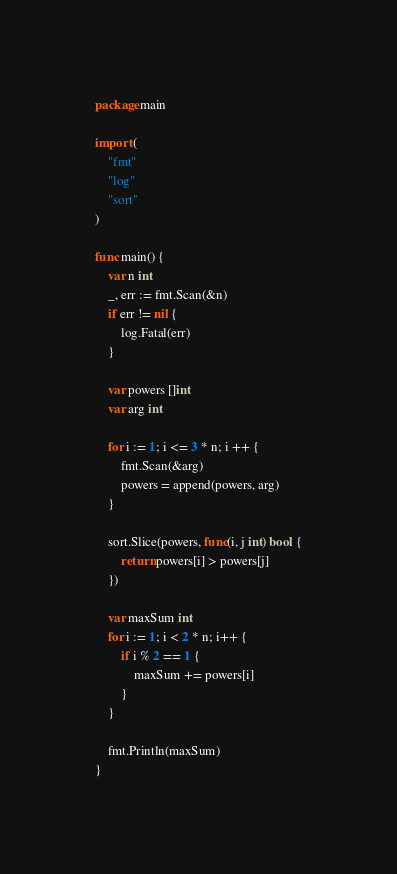Convert code to text. <code><loc_0><loc_0><loc_500><loc_500><_Go_>package main

import (
	"fmt"
	"log"
	"sort"
)

func main() {
	var n int
	_, err := fmt.Scan(&n)
	if err != nil {
		log.Fatal(err)
	}

	var powers []int
	var arg int

	for i := 1; i <= 3 * n; i ++ {
		fmt.Scan(&arg)
		powers = append(powers, arg)
	}

	sort.Slice(powers, func(i, j int) bool {
		return powers[i] > powers[j]
	})

	var maxSum int
	for i := 1; i < 2 * n; i++ {
		if i % 2 == 1 {
			maxSum += powers[i]
		}
	}

	fmt.Println(maxSum)
}
</code> 